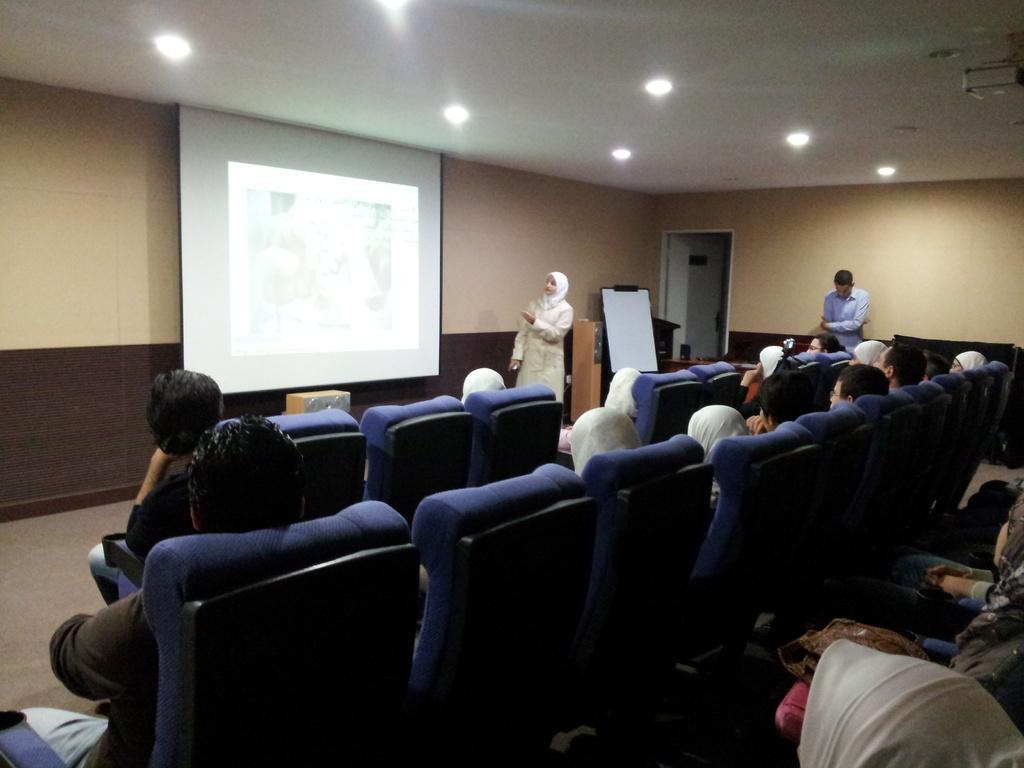How would you summarize this image in a sentence or two? At the top of the image we can see electrical lights attached to the roof, a display screen and a woman standing on the floor. At the bottom of the image we can persons sitting in the chairs and a person standing to the wall. 